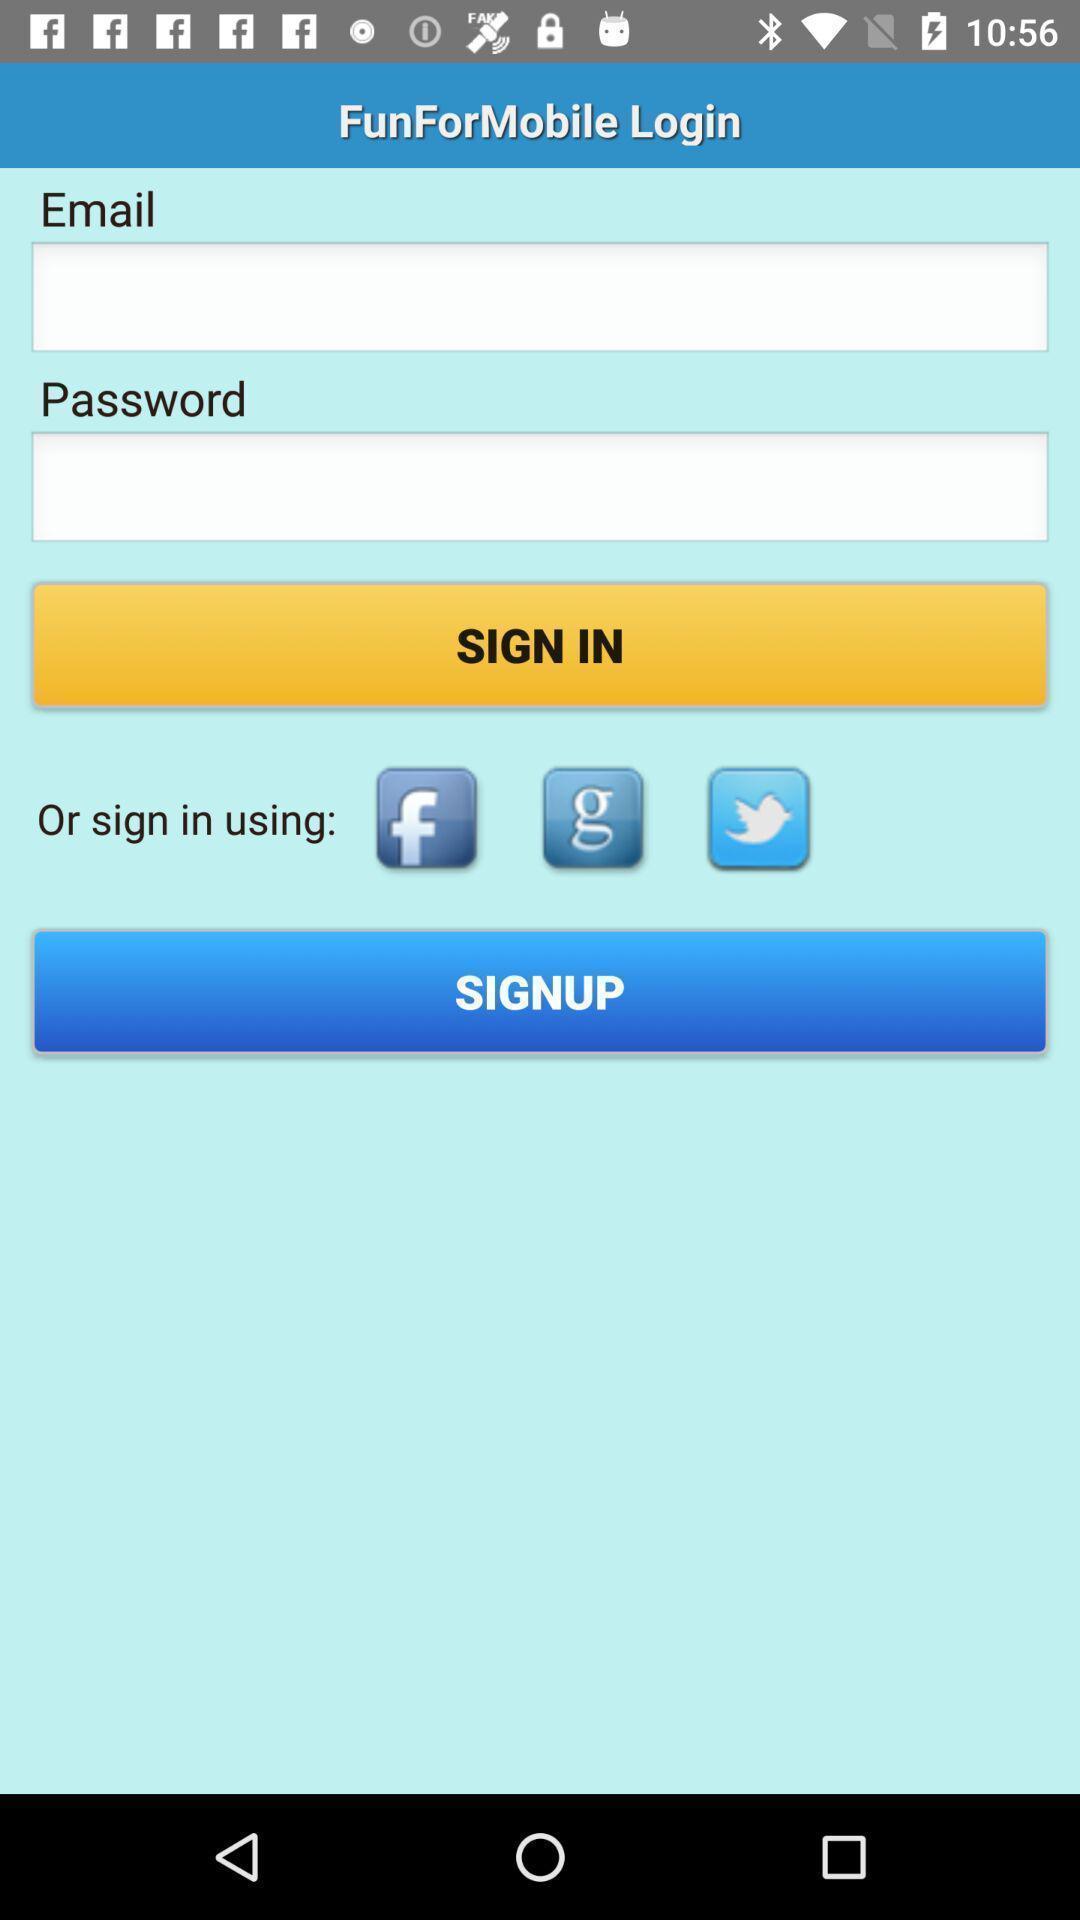Give me a narrative description of this picture. Sign up page. 